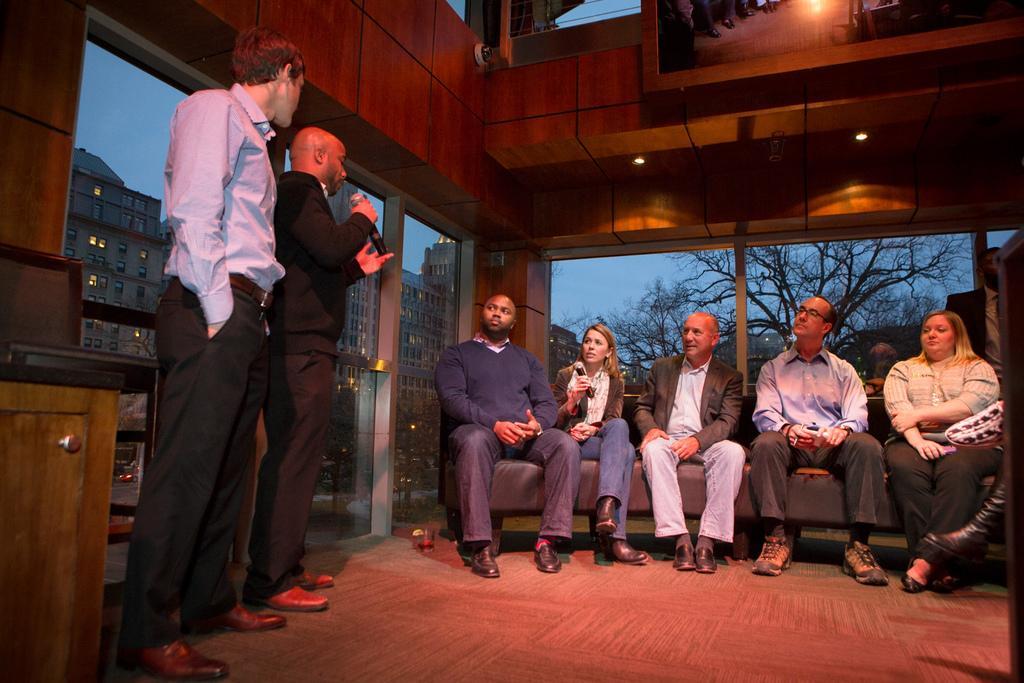In one or two sentences, can you explain what this image depicts? In this image, we can see people. Few people sitting on a couch. At the bottom, there is a floor. On the left side of the image, we can see two men standing, chair and cupboard with handle. A man is holding a microphone. In the background, we can see glass objects. Through the glasses, we can see buildings, vehicles, trees and sky. In the top right side of the image, there is a mirror. On this mirror, we can see reflections. 